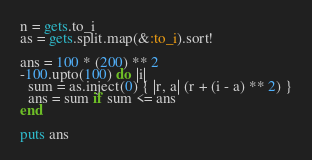Convert code to text. <code><loc_0><loc_0><loc_500><loc_500><_Ruby_>n = gets.to_i
as = gets.split.map(&:to_i).sort!

ans = 100 * (200) ** 2
-100.upto(100) do |i|
  sum = as.inject(0) { |r, a| (r + (i - a) ** 2) }
  ans = sum if sum <= ans
end

puts ans
</code> 